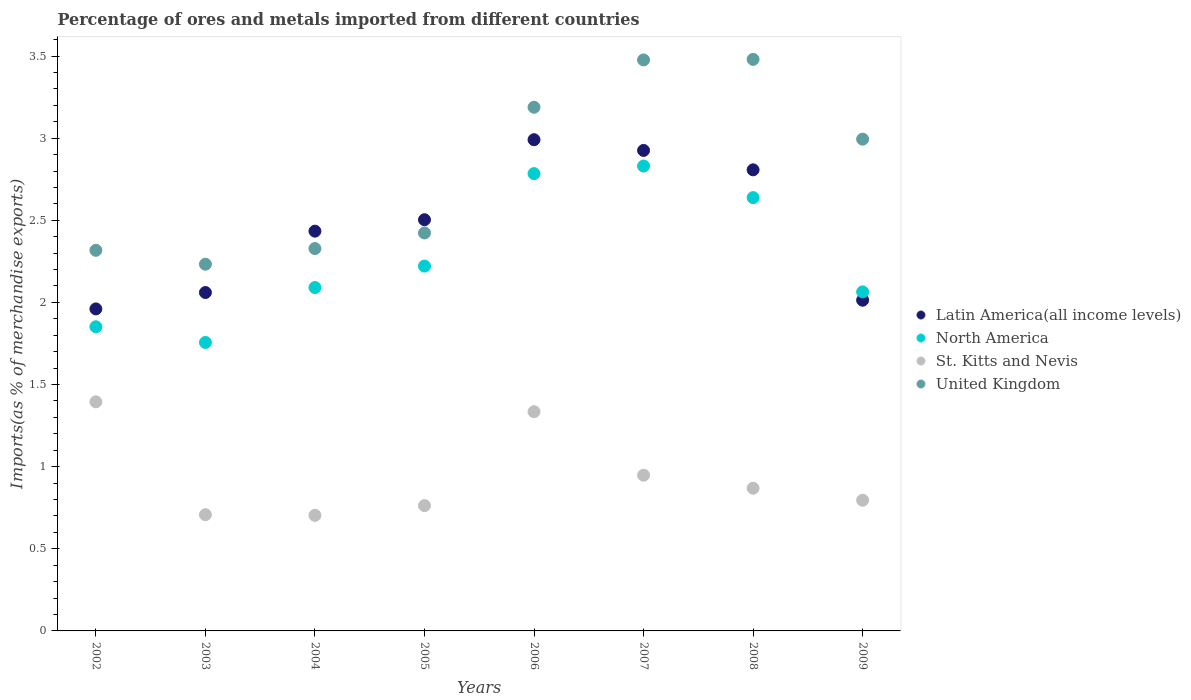How many different coloured dotlines are there?
Your answer should be compact. 4. Is the number of dotlines equal to the number of legend labels?
Keep it short and to the point. Yes. What is the percentage of imports to different countries in Latin America(all income levels) in 2007?
Provide a succinct answer. 2.93. Across all years, what is the maximum percentage of imports to different countries in United Kingdom?
Give a very brief answer. 3.48. Across all years, what is the minimum percentage of imports to different countries in Latin America(all income levels)?
Keep it short and to the point. 1.96. In which year was the percentage of imports to different countries in Latin America(all income levels) maximum?
Offer a very short reply. 2006. In which year was the percentage of imports to different countries in St. Kitts and Nevis minimum?
Provide a short and direct response. 2004. What is the total percentage of imports to different countries in St. Kitts and Nevis in the graph?
Your response must be concise. 7.52. What is the difference between the percentage of imports to different countries in North America in 2002 and that in 2005?
Your answer should be very brief. -0.37. What is the difference between the percentage of imports to different countries in St. Kitts and Nevis in 2006 and the percentage of imports to different countries in North America in 2002?
Offer a terse response. -0.52. What is the average percentage of imports to different countries in Latin America(all income levels) per year?
Make the answer very short. 2.46. In the year 2006, what is the difference between the percentage of imports to different countries in St. Kitts and Nevis and percentage of imports to different countries in North America?
Provide a succinct answer. -1.45. In how many years, is the percentage of imports to different countries in Latin America(all income levels) greater than 1.5 %?
Give a very brief answer. 8. What is the ratio of the percentage of imports to different countries in United Kingdom in 2006 to that in 2007?
Provide a short and direct response. 0.92. What is the difference between the highest and the second highest percentage of imports to different countries in Latin America(all income levels)?
Offer a terse response. 0.07. What is the difference between the highest and the lowest percentage of imports to different countries in Latin America(all income levels)?
Ensure brevity in your answer.  1.03. Is the sum of the percentage of imports to different countries in North America in 2005 and 2008 greater than the maximum percentage of imports to different countries in United Kingdom across all years?
Provide a short and direct response. Yes. Is it the case that in every year, the sum of the percentage of imports to different countries in North America and percentage of imports to different countries in United Kingdom  is greater than the sum of percentage of imports to different countries in St. Kitts and Nevis and percentage of imports to different countries in Latin America(all income levels)?
Provide a succinct answer. No. Is it the case that in every year, the sum of the percentage of imports to different countries in United Kingdom and percentage of imports to different countries in St. Kitts and Nevis  is greater than the percentage of imports to different countries in North America?
Keep it short and to the point. Yes. What is the difference between two consecutive major ticks on the Y-axis?
Your answer should be compact. 0.5. Where does the legend appear in the graph?
Ensure brevity in your answer.  Center right. How are the legend labels stacked?
Keep it short and to the point. Vertical. What is the title of the graph?
Give a very brief answer. Percentage of ores and metals imported from different countries. What is the label or title of the X-axis?
Make the answer very short. Years. What is the label or title of the Y-axis?
Keep it short and to the point. Imports(as % of merchandise exports). What is the Imports(as % of merchandise exports) of Latin America(all income levels) in 2002?
Provide a succinct answer. 1.96. What is the Imports(as % of merchandise exports) in North America in 2002?
Give a very brief answer. 1.85. What is the Imports(as % of merchandise exports) of St. Kitts and Nevis in 2002?
Provide a short and direct response. 1.39. What is the Imports(as % of merchandise exports) of United Kingdom in 2002?
Give a very brief answer. 2.32. What is the Imports(as % of merchandise exports) in Latin America(all income levels) in 2003?
Provide a short and direct response. 2.06. What is the Imports(as % of merchandise exports) of North America in 2003?
Your answer should be compact. 1.76. What is the Imports(as % of merchandise exports) in St. Kitts and Nevis in 2003?
Offer a terse response. 0.71. What is the Imports(as % of merchandise exports) of United Kingdom in 2003?
Provide a short and direct response. 2.23. What is the Imports(as % of merchandise exports) of Latin America(all income levels) in 2004?
Make the answer very short. 2.43. What is the Imports(as % of merchandise exports) in North America in 2004?
Provide a succinct answer. 2.09. What is the Imports(as % of merchandise exports) in St. Kitts and Nevis in 2004?
Your answer should be compact. 0.7. What is the Imports(as % of merchandise exports) in United Kingdom in 2004?
Your answer should be very brief. 2.33. What is the Imports(as % of merchandise exports) in Latin America(all income levels) in 2005?
Your answer should be very brief. 2.5. What is the Imports(as % of merchandise exports) of North America in 2005?
Provide a short and direct response. 2.22. What is the Imports(as % of merchandise exports) in St. Kitts and Nevis in 2005?
Ensure brevity in your answer.  0.76. What is the Imports(as % of merchandise exports) of United Kingdom in 2005?
Provide a short and direct response. 2.42. What is the Imports(as % of merchandise exports) of Latin America(all income levels) in 2006?
Provide a succinct answer. 2.99. What is the Imports(as % of merchandise exports) of North America in 2006?
Ensure brevity in your answer.  2.78. What is the Imports(as % of merchandise exports) of St. Kitts and Nevis in 2006?
Provide a succinct answer. 1.33. What is the Imports(as % of merchandise exports) of United Kingdom in 2006?
Your answer should be very brief. 3.19. What is the Imports(as % of merchandise exports) in Latin America(all income levels) in 2007?
Keep it short and to the point. 2.93. What is the Imports(as % of merchandise exports) of North America in 2007?
Offer a very short reply. 2.83. What is the Imports(as % of merchandise exports) of St. Kitts and Nevis in 2007?
Your answer should be very brief. 0.95. What is the Imports(as % of merchandise exports) of United Kingdom in 2007?
Your answer should be very brief. 3.48. What is the Imports(as % of merchandise exports) in Latin America(all income levels) in 2008?
Offer a terse response. 2.81. What is the Imports(as % of merchandise exports) in North America in 2008?
Give a very brief answer. 2.64. What is the Imports(as % of merchandise exports) of St. Kitts and Nevis in 2008?
Provide a short and direct response. 0.87. What is the Imports(as % of merchandise exports) in United Kingdom in 2008?
Provide a succinct answer. 3.48. What is the Imports(as % of merchandise exports) in Latin America(all income levels) in 2009?
Provide a succinct answer. 2.01. What is the Imports(as % of merchandise exports) of North America in 2009?
Offer a very short reply. 2.06. What is the Imports(as % of merchandise exports) in St. Kitts and Nevis in 2009?
Your answer should be very brief. 0.8. What is the Imports(as % of merchandise exports) in United Kingdom in 2009?
Offer a very short reply. 2.99. Across all years, what is the maximum Imports(as % of merchandise exports) in Latin America(all income levels)?
Your answer should be compact. 2.99. Across all years, what is the maximum Imports(as % of merchandise exports) in North America?
Provide a short and direct response. 2.83. Across all years, what is the maximum Imports(as % of merchandise exports) in St. Kitts and Nevis?
Give a very brief answer. 1.39. Across all years, what is the maximum Imports(as % of merchandise exports) in United Kingdom?
Give a very brief answer. 3.48. Across all years, what is the minimum Imports(as % of merchandise exports) in Latin America(all income levels)?
Your answer should be compact. 1.96. Across all years, what is the minimum Imports(as % of merchandise exports) of North America?
Ensure brevity in your answer.  1.76. Across all years, what is the minimum Imports(as % of merchandise exports) in St. Kitts and Nevis?
Offer a terse response. 0.7. Across all years, what is the minimum Imports(as % of merchandise exports) in United Kingdom?
Provide a succinct answer. 2.23. What is the total Imports(as % of merchandise exports) in Latin America(all income levels) in the graph?
Keep it short and to the point. 19.69. What is the total Imports(as % of merchandise exports) of North America in the graph?
Your answer should be very brief. 18.24. What is the total Imports(as % of merchandise exports) of St. Kitts and Nevis in the graph?
Provide a succinct answer. 7.52. What is the total Imports(as % of merchandise exports) of United Kingdom in the graph?
Keep it short and to the point. 22.44. What is the difference between the Imports(as % of merchandise exports) of Latin America(all income levels) in 2002 and that in 2003?
Ensure brevity in your answer.  -0.1. What is the difference between the Imports(as % of merchandise exports) of North America in 2002 and that in 2003?
Your response must be concise. 0.1. What is the difference between the Imports(as % of merchandise exports) in St. Kitts and Nevis in 2002 and that in 2003?
Keep it short and to the point. 0.69. What is the difference between the Imports(as % of merchandise exports) in United Kingdom in 2002 and that in 2003?
Offer a terse response. 0.08. What is the difference between the Imports(as % of merchandise exports) in Latin America(all income levels) in 2002 and that in 2004?
Make the answer very short. -0.47. What is the difference between the Imports(as % of merchandise exports) of North America in 2002 and that in 2004?
Your answer should be compact. -0.24. What is the difference between the Imports(as % of merchandise exports) of St. Kitts and Nevis in 2002 and that in 2004?
Give a very brief answer. 0.69. What is the difference between the Imports(as % of merchandise exports) of United Kingdom in 2002 and that in 2004?
Offer a terse response. -0.01. What is the difference between the Imports(as % of merchandise exports) of Latin America(all income levels) in 2002 and that in 2005?
Give a very brief answer. -0.54. What is the difference between the Imports(as % of merchandise exports) in North America in 2002 and that in 2005?
Offer a terse response. -0.37. What is the difference between the Imports(as % of merchandise exports) of St. Kitts and Nevis in 2002 and that in 2005?
Provide a succinct answer. 0.63. What is the difference between the Imports(as % of merchandise exports) in United Kingdom in 2002 and that in 2005?
Your answer should be very brief. -0.11. What is the difference between the Imports(as % of merchandise exports) of Latin America(all income levels) in 2002 and that in 2006?
Provide a short and direct response. -1.03. What is the difference between the Imports(as % of merchandise exports) of North America in 2002 and that in 2006?
Your response must be concise. -0.93. What is the difference between the Imports(as % of merchandise exports) in St. Kitts and Nevis in 2002 and that in 2006?
Your answer should be compact. 0.06. What is the difference between the Imports(as % of merchandise exports) of United Kingdom in 2002 and that in 2006?
Offer a terse response. -0.87. What is the difference between the Imports(as % of merchandise exports) in Latin America(all income levels) in 2002 and that in 2007?
Provide a short and direct response. -0.96. What is the difference between the Imports(as % of merchandise exports) of North America in 2002 and that in 2007?
Your answer should be compact. -0.98. What is the difference between the Imports(as % of merchandise exports) in St. Kitts and Nevis in 2002 and that in 2007?
Offer a very short reply. 0.45. What is the difference between the Imports(as % of merchandise exports) of United Kingdom in 2002 and that in 2007?
Give a very brief answer. -1.16. What is the difference between the Imports(as % of merchandise exports) of Latin America(all income levels) in 2002 and that in 2008?
Make the answer very short. -0.85. What is the difference between the Imports(as % of merchandise exports) of North America in 2002 and that in 2008?
Keep it short and to the point. -0.79. What is the difference between the Imports(as % of merchandise exports) in St. Kitts and Nevis in 2002 and that in 2008?
Offer a terse response. 0.53. What is the difference between the Imports(as % of merchandise exports) of United Kingdom in 2002 and that in 2008?
Give a very brief answer. -1.16. What is the difference between the Imports(as % of merchandise exports) of Latin America(all income levels) in 2002 and that in 2009?
Provide a short and direct response. -0.05. What is the difference between the Imports(as % of merchandise exports) in North America in 2002 and that in 2009?
Give a very brief answer. -0.21. What is the difference between the Imports(as % of merchandise exports) of St. Kitts and Nevis in 2002 and that in 2009?
Ensure brevity in your answer.  0.6. What is the difference between the Imports(as % of merchandise exports) of United Kingdom in 2002 and that in 2009?
Keep it short and to the point. -0.68. What is the difference between the Imports(as % of merchandise exports) in Latin America(all income levels) in 2003 and that in 2004?
Your response must be concise. -0.37. What is the difference between the Imports(as % of merchandise exports) of North America in 2003 and that in 2004?
Provide a succinct answer. -0.33. What is the difference between the Imports(as % of merchandise exports) in St. Kitts and Nevis in 2003 and that in 2004?
Give a very brief answer. 0. What is the difference between the Imports(as % of merchandise exports) in United Kingdom in 2003 and that in 2004?
Provide a short and direct response. -0.1. What is the difference between the Imports(as % of merchandise exports) in Latin America(all income levels) in 2003 and that in 2005?
Offer a very short reply. -0.44. What is the difference between the Imports(as % of merchandise exports) of North America in 2003 and that in 2005?
Ensure brevity in your answer.  -0.47. What is the difference between the Imports(as % of merchandise exports) in St. Kitts and Nevis in 2003 and that in 2005?
Your answer should be compact. -0.06. What is the difference between the Imports(as % of merchandise exports) in United Kingdom in 2003 and that in 2005?
Offer a terse response. -0.19. What is the difference between the Imports(as % of merchandise exports) of Latin America(all income levels) in 2003 and that in 2006?
Make the answer very short. -0.93. What is the difference between the Imports(as % of merchandise exports) in North America in 2003 and that in 2006?
Your response must be concise. -1.03. What is the difference between the Imports(as % of merchandise exports) of St. Kitts and Nevis in 2003 and that in 2006?
Make the answer very short. -0.63. What is the difference between the Imports(as % of merchandise exports) in United Kingdom in 2003 and that in 2006?
Provide a short and direct response. -0.96. What is the difference between the Imports(as % of merchandise exports) of Latin America(all income levels) in 2003 and that in 2007?
Ensure brevity in your answer.  -0.87. What is the difference between the Imports(as % of merchandise exports) in North America in 2003 and that in 2007?
Keep it short and to the point. -1.07. What is the difference between the Imports(as % of merchandise exports) of St. Kitts and Nevis in 2003 and that in 2007?
Provide a short and direct response. -0.24. What is the difference between the Imports(as % of merchandise exports) of United Kingdom in 2003 and that in 2007?
Your response must be concise. -1.24. What is the difference between the Imports(as % of merchandise exports) of Latin America(all income levels) in 2003 and that in 2008?
Give a very brief answer. -0.75. What is the difference between the Imports(as % of merchandise exports) in North America in 2003 and that in 2008?
Offer a very short reply. -0.88. What is the difference between the Imports(as % of merchandise exports) in St. Kitts and Nevis in 2003 and that in 2008?
Your answer should be compact. -0.16. What is the difference between the Imports(as % of merchandise exports) in United Kingdom in 2003 and that in 2008?
Your answer should be compact. -1.25. What is the difference between the Imports(as % of merchandise exports) of Latin America(all income levels) in 2003 and that in 2009?
Make the answer very short. 0.05. What is the difference between the Imports(as % of merchandise exports) of North America in 2003 and that in 2009?
Ensure brevity in your answer.  -0.31. What is the difference between the Imports(as % of merchandise exports) of St. Kitts and Nevis in 2003 and that in 2009?
Your answer should be very brief. -0.09. What is the difference between the Imports(as % of merchandise exports) in United Kingdom in 2003 and that in 2009?
Your answer should be very brief. -0.76. What is the difference between the Imports(as % of merchandise exports) of Latin America(all income levels) in 2004 and that in 2005?
Your answer should be very brief. -0.07. What is the difference between the Imports(as % of merchandise exports) in North America in 2004 and that in 2005?
Your answer should be compact. -0.13. What is the difference between the Imports(as % of merchandise exports) of St. Kitts and Nevis in 2004 and that in 2005?
Provide a succinct answer. -0.06. What is the difference between the Imports(as % of merchandise exports) of United Kingdom in 2004 and that in 2005?
Provide a short and direct response. -0.1. What is the difference between the Imports(as % of merchandise exports) of Latin America(all income levels) in 2004 and that in 2006?
Your answer should be compact. -0.56. What is the difference between the Imports(as % of merchandise exports) in North America in 2004 and that in 2006?
Your response must be concise. -0.69. What is the difference between the Imports(as % of merchandise exports) in St. Kitts and Nevis in 2004 and that in 2006?
Provide a short and direct response. -0.63. What is the difference between the Imports(as % of merchandise exports) in United Kingdom in 2004 and that in 2006?
Your answer should be very brief. -0.86. What is the difference between the Imports(as % of merchandise exports) in Latin America(all income levels) in 2004 and that in 2007?
Keep it short and to the point. -0.49. What is the difference between the Imports(as % of merchandise exports) in North America in 2004 and that in 2007?
Provide a short and direct response. -0.74. What is the difference between the Imports(as % of merchandise exports) of St. Kitts and Nevis in 2004 and that in 2007?
Keep it short and to the point. -0.24. What is the difference between the Imports(as % of merchandise exports) of United Kingdom in 2004 and that in 2007?
Provide a short and direct response. -1.15. What is the difference between the Imports(as % of merchandise exports) of Latin America(all income levels) in 2004 and that in 2008?
Offer a terse response. -0.37. What is the difference between the Imports(as % of merchandise exports) of North America in 2004 and that in 2008?
Offer a terse response. -0.55. What is the difference between the Imports(as % of merchandise exports) in St. Kitts and Nevis in 2004 and that in 2008?
Give a very brief answer. -0.17. What is the difference between the Imports(as % of merchandise exports) of United Kingdom in 2004 and that in 2008?
Provide a short and direct response. -1.15. What is the difference between the Imports(as % of merchandise exports) in Latin America(all income levels) in 2004 and that in 2009?
Make the answer very short. 0.42. What is the difference between the Imports(as % of merchandise exports) of North America in 2004 and that in 2009?
Provide a succinct answer. 0.03. What is the difference between the Imports(as % of merchandise exports) of St. Kitts and Nevis in 2004 and that in 2009?
Provide a succinct answer. -0.09. What is the difference between the Imports(as % of merchandise exports) in United Kingdom in 2004 and that in 2009?
Keep it short and to the point. -0.67. What is the difference between the Imports(as % of merchandise exports) in Latin America(all income levels) in 2005 and that in 2006?
Your answer should be compact. -0.49. What is the difference between the Imports(as % of merchandise exports) in North America in 2005 and that in 2006?
Give a very brief answer. -0.56. What is the difference between the Imports(as % of merchandise exports) in St. Kitts and Nevis in 2005 and that in 2006?
Ensure brevity in your answer.  -0.57. What is the difference between the Imports(as % of merchandise exports) of United Kingdom in 2005 and that in 2006?
Provide a succinct answer. -0.77. What is the difference between the Imports(as % of merchandise exports) of Latin America(all income levels) in 2005 and that in 2007?
Your answer should be very brief. -0.42. What is the difference between the Imports(as % of merchandise exports) of North America in 2005 and that in 2007?
Keep it short and to the point. -0.61. What is the difference between the Imports(as % of merchandise exports) in St. Kitts and Nevis in 2005 and that in 2007?
Offer a terse response. -0.19. What is the difference between the Imports(as % of merchandise exports) of United Kingdom in 2005 and that in 2007?
Offer a terse response. -1.05. What is the difference between the Imports(as % of merchandise exports) in Latin America(all income levels) in 2005 and that in 2008?
Keep it short and to the point. -0.3. What is the difference between the Imports(as % of merchandise exports) of North America in 2005 and that in 2008?
Your answer should be very brief. -0.42. What is the difference between the Imports(as % of merchandise exports) in St. Kitts and Nevis in 2005 and that in 2008?
Provide a short and direct response. -0.11. What is the difference between the Imports(as % of merchandise exports) in United Kingdom in 2005 and that in 2008?
Offer a very short reply. -1.06. What is the difference between the Imports(as % of merchandise exports) in Latin America(all income levels) in 2005 and that in 2009?
Your answer should be very brief. 0.49. What is the difference between the Imports(as % of merchandise exports) of North America in 2005 and that in 2009?
Your answer should be very brief. 0.16. What is the difference between the Imports(as % of merchandise exports) in St. Kitts and Nevis in 2005 and that in 2009?
Your response must be concise. -0.03. What is the difference between the Imports(as % of merchandise exports) in United Kingdom in 2005 and that in 2009?
Give a very brief answer. -0.57. What is the difference between the Imports(as % of merchandise exports) of Latin America(all income levels) in 2006 and that in 2007?
Keep it short and to the point. 0.07. What is the difference between the Imports(as % of merchandise exports) in North America in 2006 and that in 2007?
Ensure brevity in your answer.  -0.05. What is the difference between the Imports(as % of merchandise exports) of St. Kitts and Nevis in 2006 and that in 2007?
Your answer should be compact. 0.39. What is the difference between the Imports(as % of merchandise exports) of United Kingdom in 2006 and that in 2007?
Your response must be concise. -0.29. What is the difference between the Imports(as % of merchandise exports) in Latin America(all income levels) in 2006 and that in 2008?
Your answer should be very brief. 0.18. What is the difference between the Imports(as % of merchandise exports) in North America in 2006 and that in 2008?
Make the answer very short. 0.15. What is the difference between the Imports(as % of merchandise exports) of St. Kitts and Nevis in 2006 and that in 2008?
Your answer should be very brief. 0.47. What is the difference between the Imports(as % of merchandise exports) in United Kingdom in 2006 and that in 2008?
Make the answer very short. -0.29. What is the difference between the Imports(as % of merchandise exports) of Latin America(all income levels) in 2006 and that in 2009?
Provide a short and direct response. 0.98. What is the difference between the Imports(as % of merchandise exports) in North America in 2006 and that in 2009?
Your response must be concise. 0.72. What is the difference between the Imports(as % of merchandise exports) of St. Kitts and Nevis in 2006 and that in 2009?
Ensure brevity in your answer.  0.54. What is the difference between the Imports(as % of merchandise exports) of United Kingdom in 2006 and that in 2009?
Your answer should be very brief. 0.19. What is the difference between the Imports(as % of merchandise exports) of Latin America(all income levels) in 2007 and that in 2008?
Your answer should be very brief. 0.12. What is the difference between the Imports(as % of merchandise exports) of North America in 2007 and that in 2008?
Make the answer very short. 0.19. What is the difference between the Imports(as % of merchandise exports) in St. Kitts and Nevis in 2007 and that in 2008?
Provide a short and direct response. 0.08. What is the difference between the Imports(as % of merchandise exports) of United Kingdom in 2007 and that in 2008?
Provide a short and direct response. -0. What is the difference between the Imports(as % of merchandise exports) of Latin America(all income levels) in 2007 and that in 2009?
Ensure brevity in your answer.  0.91. What is the difference between the Imports(as % of merchandise exports) of North America in 2007 and that in 2009?
Your answer should be very brief. 0.77. What is the difference between the Imports(as % of merchandise exports) in St. Kitts and Nevis in 2007 and that in 2009?
Give a very brief answer. 0.15. What is the difference between the Imports(as % of merchandise exports) of United Kingdom in 2007 and that in 2009?
Keep it short and to the point. 0.48. What is the difference between the Imports(as % of merchandise exports) in Latin America(all income levels) in 2008 and that in 2009?
Offer a very short reply. 0.79. What is the difference between the Imports(as % of merchandise exports) in North America in 2008 and that in 2009?
Offer a very short reply. 0.57. What is the difference between the Imports(as % of merchandise exports) of St. Kitts and Nevis in 2008 and that in 2009?
Your response must be concise. 0.07. What is the difference between the Imports(as % of merchandise exports) of United Kingdom in 2008 and that in 2009?
Offer a terse response. 0.49. What is the difference between the Imports(as % of merchandise exports) in Latin America(all income levels) in 2002 and the Imports(as % of merchandise exports) in North America in 2003?
Keep it short and to the point. 0.2. What is the difference between the Imports(as % of merchandise exports) of Latin America(all income levels) in 2002 and the Imports(as % of merchandise exports) of St. Kitts and Nevis in 2003?
Ensure brevity in your answer.  1.25. What is the difference between the Imports(as % of merchandise exports) in Latin America(all income levels) in 2002 and the Imports(as % of merchandise exports) in United Kingdom in 2003?
Your answer should be compact. -0.27. What is the difference between the Imports(as % of merchandise exports) in North America in 2002 and the Imports(as % of merchandise exports) in St. Kitts and Nevis in 2003?
Your response must be concise. 1.14. What is the difference between the Imports(as % of merchandise exports) of North America in 2002 and the Imports(as % of merchandise exports) of United Kingdom in 2003?
Ensure brevity in your answer.  -0.38. What is the difference between the Imports(as % of merchandise exports) in St. Kitts and Nevis in 2002 and the Imports(as % of merchandise exports) in United Kingdom in 2003?
Your answer should be compact. -0.84. What is the difference between the Imports(as % of merchandise exports) of Latin America(all income levels) in 2002 and the Imports(as % of merchandise exports) of North America in 2004?
Ensure brevity in your answer.  -0.13. What is the difference between the Imports(as % of merchandise exports) of Latin America(all income levels) in 2002 and the Imports(as % of merchandise exports) of St. Kitts and Nevis in 2004?
Your answer should be very brief. 1.26. What is the difference between the Imports(as % of merchandise exports) of Latin America(all income levels) in 2002 and the Imports(as % of merchandise exports) of United Kingdom in 2004?
Offer a terse response. -0.37. What is the difference between the Imports(as % of merchandise exports) in North America in 2002 and the Imports(as % of merchandise exports) in St. Kitts and Nevis in 2004?
Make the answer very short. 1.15. What is the difference between the Imports(as % of merchandise exports) in North America in 2002 and the Imports(as % of merchandise exports) in United Kingdom in 2004?
Provide a succinct answer. -0.48. What is the difference between the Imports(as % of merchandise exports) in St. Kitts and Nevis in 2002 and the Imports(as % of merchandise exports) in United Kingdom in 2004?
Keep it short and to the point. -0.93. What is the difference between the Imports(as % of merchandise exports) of Latin America(all income levels) in 2002 and the Imports(as % of merchandise exports) of North America in 2005?
Ensure brevity in your answer.  -0.26. What is the difference between the Imports(as % of merchandise exports) in Latin America(all income levels) in 2002 and the Imports(as % of merchandise exports) in St. Kitts and Nevis in 2005?
Offer a very short reply. 1.2. What is the difference between the Imports(as % of merchandise exports) in Latin America(all income levels) in 2002 and the Imports(as % of merchandise exports) in United Kingdom in 2005?
Provide a succinct answer. -0.46. What is the difference between the Imports(as % of merchandise exports) in North America in 2002 and the Imports(as % of merchandise exports) in St. Kitts and Nevis in 2005?
Provide a succinct answer. 1.09. What is the difference between the Imports(as % of merchandise exports) of North America in 2002 and the Imports(as % of merchandise exports) of United Kingdom in 2005?
Keep it short and to the point. -0.57. What is the difference between the Imports(as % of merchandise exports) in St. Kitts and Nevis in 2002 and the Imports(as % of merchandise exports) in United Kingdom in 2005?
Provide a succinct answer. -1.03. What is the difference between the Imports(as % of merchandise exports) of Latin America(all income levels) in 2002 and the Imports(as % of merchandise exports) of North America in 2006?
Offer a terse response. -0.82. What is the difference between the Imports(as % of merchandise exports) of Latin America(all income levels) in 2002 and the Imports(as % of merchandise exports) of St. Kitts and Nevis in 2006?
Make the answer very short. 0.63. What is the difference between the Imports(as % of merchandise exports) of Latin America(all income levels) in 2002 and the Imports(as % of merchandise exports) of United Kingdom in 2006?
Your answer should be compact. -1.23. What is the difference between the Imports(as % of merchandise exports) of North America in 2002 and the Imports(as % of merchandise exports) of St. Kitts and Nevis in 2006?
Provide a succinct answer. 0.52. What is the difference between the Imports(as % of merchandise exports) of North America in 2002 and the Imports(as % of merchandise exports) of United Kingdom in 2006?
Your answer should be very brief. -1.34. What is the difference between the Imports(as % of merchandise exports) in St. Kitts and Nevis in 2002 and the Imports(as % of merchandise exports) in United Kingdom in 2006?
Ensure brevity in your answer.  -1.79. What is the difference between the Imports(as % of merchandise exports) of Latin America(all income levels) in 2002 and the Imports(as % of merchandise exports) of North America in 2007?
Ensure brevity in your answer.  -0.87. What is the difference between the Imports(as % of merchandise exports) in Latin America(all income levels) in 2002 and the Imports(as % of merchandise exports) in St. Kitts and Nevis in 2007?
Provide a succinct answer. 1.01. What is the difference between the Imports(as % of merchandise exports) in Latin America(all income levels) in 2002 and the Imports(as % of merchandise exports) in United Kingdom in 2007?
Keep it short and to the point. -1.52. What is the difference between the Imports(as % of merchandise exports) of North America in 2002 and the Imports(as % of merchandise exports) of St. Kitts and Nevis in 2007?
Offer a terse response. 0.9. What is the difference between the Imports(as % of merchandise exports) of North America in 2002 and the Imports(as % of merchandise exports) of United Kingdom in 2007?
Make the answer very short. -1.62. What is the difference between the Imports(as % of merchandise exports) in St. Kitts and Nevis in 2002 and the Imports(as % of merchandise exports) in United Kingdom in 2007?
Keep it short and to the point. -2.08. What is the difference between the Imports(as % of merchandise exports) in Latin America(all income levels) in 2002 and the Imports(as % of merchandise exports) in North America in 2008?
Your response must be concise. -0.68. What is the difference between the Imports(as % of merchandise exports) of Latin America(all income levels) in 2002 and the Imports(as % of merchandise exports) of St. Kitts and Nevis in 2008?
Your response must be concise. 1.09. What is the difference between the Imports(as % of merchandise exports) in Latin America(all income levels) in 2002 and the Imports(as % of merchandise exports) in United Kingdom in 2008?
Provide a succinct answer. -1.52. What is the difference between the Imports(as % of merchandise exports) of North America in 2002 and the Imports(as % of merchandise exports) of St. Kitts and Nevis in 2008?
Make the answer very short. 0.98. What is the difference between the Imports(as % of merchandise exports) in North America in 2002 and the Imports(as % of merchandise exports) in United Kingdom in 2008?
Your response must be concise. -1.63. What is the difference between the Imports(as % of merchandise exports) of St. Kitts and Nevis in 2002 and the Imports(as % of merchandise exports) of United Kingdom in 2008?
Provide a succinct answer. -2.08. What is the difference between the Imports(as % of merchandise exports) of Latin America(all income levels) in 2002 and the Imports(as % of merchandise exports) of North America in 2009?
Your answer should be compact. -0.1. What is the difference between the Imports(as % of merchandise exports) of Latin America(all income levels) in 2002 and the Imports(as % of merchandise exports) of St. Kitts and Nevis in 2009?
Your response must be concise. 1.16. What is the difference between the Imports(as % of merchandise exports) in Latin America(all income levels) in 2002 and the Imports(as % of merchandise exports) in United Kingdom in 2009?
Offer a very short reply. -1.03. What is the difference between the Imports(as % of merchandise exports) in North America in 2002 and the Imports(as % of merchandise exports) in St. Kitts and Nevis in 2009?
Offer a terse response. 1.06. What is the difference between the Imports(as % of merchandise exports) of North America in 2002 and the Imports(as % of merchandise exports) of United Kingdom in 2009?
Make the answer very short. -1.14. What is the difference between the Imports(as % of merchandise exports) in St. Kitts and Nevis in 2002 and the Imports(as % of merchandise exports) in United Kingdom in 2009?
Your answer should be very brief. -1.6. What is the difference between the Imports(as % of merchandise exports) of Latin America(all income levels) in 2003 and the Imports(as % of merchandise exports) of North America in 2004?
Provide a short and direct response. -0.03. What is the difference between the Imports(as % of merchandise exports) in Latin America(all income levels) in 2003 and the Imports(as % of merchandise exports) in St. Kitts and Nevis in 2004?
Make the answer very short. 1.36. What is the difference between the Imports(as % of merchandise exports) in Latin America(all income levels) in 2003 and the Imports(as % of merchandise exports) in United Kingdom in 2004?
Provide a short and direct response. -0.27. What is the difference between the Imports(as % of merchandise exports) in North America in 2003 and the Imports(as % of merchandise exports) in St. Kitts and Nevis in 2004?
Keep it short and to the point. 1.05. What is the difference between the Imports(as % of merchandise exports) of North America in 2003 and the Imports(as % of merchandise exports) of United Kingdom in 2004?
Offer a very short reply. -0.57. What is the difference between the Imports(as % of merchandise exports) in St. Kitts and Nevis in 2003 and the Imports(as % of merchandise exports) in United Kingdom in 2004?
Offer a terse response. -1.62. What is the difference between the Imports(as % of merchandise exports) in Latin America(all income levels) in 2003 and the Imports(as % of merchandise exports) in North America in 2005?
Provide a short and direct response. -0.16. What is the difference between the Imports(as % of merchandise exports) in Latin America(all income levels) in 2003 and the Imports(as % of merchandise exports) in St. Kitts and Nevis in 2005?
Offer a very short reply. 1.3. What is the difference between the Imports(as % of merchandise exports) of Latin America(all income levels) in 2003 and the Imports(as % of merchandise exports) of United Kingdom in 2005?
Ensure brevity in your answer.  -0.36. What is the difference between the Imports(as % of merchandise exports) of North America in 2003 and the Imports(as % of merchandise exports) of United Kingdom in 2005?
Offer a very short reply. -0.67. What is the difference between the Imports(as % of merchandise exports) in St. Kitts and Nevis in 2003 and the Imports(as % of merchandise exports) in United Kingdom in 2005?
Offer a terse response. -1.72. What is the difference between the Imports(as % of merchandise exports) in Latin America(all income levels) in 2003 and the Imports(as % of merchandise exports) in North America in 2006?
Make the answer very short. -0.72. What is the difference between the Imports(as % of merchandise exports) in Latin America(all income levels) in 2003 and the Imports(as % of merchandise exports) in St. Kitts and Nevis in 2006?
Your answer should be very brief. 0.73. What is the difference between the Imports(as % of merchandise exports) in Latin America(all income levels) in 2003 and the Imports(as % of merchandise exports) in United Kingdom in 2006?
Provide a short and direct response. -1.13. What is the difference between the Imports(as % of merchandise exports) of North America in 2003 and the Imports(as % of merchandise exports) of St. Kitts and Nevis in 2006?
Keep it short and to the point. 0.42. What is the difference between the Imports(as % of merchandise exports) of North America in 2003 and the Imports(as % of merchandise exports) of United Kingdom in 2006?
Keep it short and to the point. -1.43. What is the difference between the Imports(as % of merchandise exports) of St. Kitts and Nevis in 2003 and the Imports(as % of merchandise exports) of United Kingdom in 2006?
Give a very brief answer. -2.48. What is the difference between the Imports(as % of merchandise exports) of Latin America(all income levels) in 2003 and the Imports(as % of merchandise exports) of North America in 2007?
Provide a succinct answer. -0.77. What is the difference between the Imports(as % of merchandise exports) of Latin America(all income levels) in 2003 and the Imports(as % of merchandise exports) of St. Kitts and Nevis in 2007?
Make the answer very short. 1.11. What is the difference between the Imports(as % of merchandise exports) in Latin America(all income levels) in 2003 and the Imports(as % of merchandise exports) in United Kingdom in 2007?
Make the answer very short. -1.42. What is the difference between the Imports(as % of merchandise exports) of North America in 2003 and the Imports(as % of merchandise exports) of St. Kitts and Nevis in 2007?
Your answer should be compact. 0.81. What is the difference between the Imports(as % of merchandise exports) of North America in 2003 and the Imports(as % of merchandise exports) of United Kingdom in 2007?
Your response must be concise. -1.72. What is the difference between the Imports(as % of merchandise exports) in St. Kitts and Nevis in 2003 and the Imports(as % of merchandise exports) in United Kingdom in 2007?
Your response must be concise. -2.77. What is the difference between the Imports(as % of merchandise exports) in Latin America(all income levels) in 2003 and the Imports(as % of merchandise exports) in North America in 2008?
Keep it short and to the point. -0.58. What is the difference between the Imports(as % of merchandise exports) in Latin America(all income levels) in 2003 and the Imports(as % of merchandise exports) in St. Kitts and Nevis in 2008?
Offer a terse response. 1.19. What is the difference between the Imports(as % of merchandise exports) in Latin America(all income levels) in 2003 and the Imports(as % of merchandise exports) in United Kingdom in 2008?
Make the answer very short. -1.42. What is the difference between the Imports(as % of merchandise exports) of North America in 2003 and the Imports(as % of merchandise exports) of St. Kitts and Nevis in 2008?
Provide a short and direct response. 0.89. What is the difference between the Imports(as % of merchandise exports) in North America in 2003 and the Imports(as % of merchandise exports) in United Kingdom in 2008?
Give a very brief answer. -1.72. What is the difference between the Imports(as % of merchandise exports) of St. Kitts and Nevis in 2003 and the Imports(as % of merchandise exports) of United Kingdom in 2008?
Offer a terse response. -2.77. What is the difference between the Imports(as % of merchandise exports) of Latin America(all income levels) in 2003 and the Imports(as % of merchandise exports) of North America in 2009?
Provide a short and direct response. -0. What is the difference between the Imports(as % of merchandise exports) of Latin America(all income levels) in 2003 and the Imports(as % of merchandise exports) of St. Kitts and Nevis in 2009?
Give a very brief answer. 1.26. What is the difference between the Imports(as % of merchandise exports) in Latin America(all income levels) in 2003 and the Imports(as % of merchandise exports) in United Kingdom in 2009?
Offer a very short reply. -0.93. What is the difference between the Imports(as % of merchandise exports) of North America in 2003 and the Imports(as % of merchandise exports) of St. Kitts and Nevis in 2009?
Ensure brevity in your answer.  0.96. What is the difference between the Imports(as % of merchandise exports) in North America in 2003 and the Imports(as % of merchandise exports) in United Kingdom in 2009?
Provide a short and direct response. -1.24. What is the difference between the Imports(as % of merchandise exports) in St. Kitts and Nevis in 2003 and the Imports(as % of merchandise exports) in United Kingdom in 2009?
Your answer should be very brief. -2.29. What is the difference between the Imports(as % of merchandise exports) in Latin America(all income levels) in 2004 and the Imports(as % of merchandise exports) in North America in 2005?
Ensure brevity in your answer.  0.21. What is the difference between the Imports(as % of merchandise exports) in Latin America(all income levels) in 2004 and the Imports(as % of merchandise exports) in St. Kitts and Nevis in 2005?
Make the answer very short. 1.67. What is the difference between the Imports(as % of merchandise exports) in Latin America(all income levels) in 2004 and the Imports(as % of merchandise exports) in United Kingdom in 2005?
Make the answer very short. 0.01. What is the difference between the Imports(as % of merchandise exports) in North America in 2004 and the Imports(as % of merchandise exports) in St. Kitts and Nevis in 2005?
Your answer should be compact. 1.33. What is the difference between the Imports(as % of merchandise exports) in North America in 2004 and the Imports(as % of merchandise exports) in United Kingdom in 2005?
Keep it short and to the point. -0.33. What is the difference between the Imports(as % of merchandise exports) in St. Kitts and Nevis in 2004 and the Imports(as % of merchandise exports) in United Kingdom in 2005?
Provide a succinct answer. -1.72. What is the difference between the Imports(as % of merchandise exports) of Latin America(all income levels) in 2004 and the Imports(as % of merchandise exports) of North America in 2006?
Ensure brevity in your answer.  -0.35. What is the difference between the Imports(as % of merchandise exports) in Latin America(all income levels) in 2004 and the Imports(as % of merchandise exports) in St. Kitts and Nevis in 2006?
Make the answer very short. 1.1. What is the difference between the Imports(as % of merchandise exports) of Latin America(all income levels) in 2004 and the Imports(as % of merchandise exports) of United Kingdom in 2006?
Make the answer very short. -0.75. What is the difference between the Imports(as % of merchandise exports) in North America in 2004 and the Imports(as % of merchandise exports) in St. Kitts and Nevis in 2006?
Your answer should be compact. 0.76. What is the difference between the Imports(as % of merchandise exports) in North America in 2004 and the Imports(as % of merchandise exports) in United Kingdom in 2006?
Your answer should be compact. -1.1. What is the difference between the Imports(as % of merchandise exports) in St. Kitts and Nevis in 2004 and the Imports(as % of merchandise exports) in United Kingdom in 2006?
Your response must be concise. -2.48. What is the difference between the Imports(as % of merchandise exports) in Latin America(all income levels) in 2004 and the Imports(as % of merchandise exports) in North America in 2007?
Your answer should be compact. -0.4. What is the difference between the Imports(as % of merchandise exports) in Latin America(all income levels) in 2004 and the Imports(as % of merchandise exports) in St. Kitts and Nevis in 2007?
Ensure brevity in your answer.  1.49. What is the difference between the Imports(as % of merchandise exports) in Latin America(all income levels) in 2004 and the Imports(as % of merchandise exports) in United Kingdom in 2007?
Provide a short and direct response. -1.04. What is the difference between the Imports(as % of merchandise exports) of North America in 2004 and the Imports(as % of merchandise exports) of St. Kitts and Nevis in 2007?
Your answer should be very brief. 1.14. What is the difference between the Imports(as % of merchandise exports) of North America in 2004 and the Imports(as % of merchandise exports) of United Kingdom in 2007?
Your answer should be compact. -1.39. What is the difference between the Imports(as % of merchandise exports) in St. Kitts and Nevis in 2004 and the Imports(as % of merchandise exports) in United Kingdom in 2007?
Your answer should be compact. -2.77. What is the difference between the Imports(as % of merchandise exports) in Latin America(all income levels) in 2004 and the Imports(as % of merchandise exports) in North America in 2008?
Ensure brevity in your answer.  -0.2. What is the difference between the Imports(as % of merchandise exports) of Latin America(all income levels) in 2004 and the Imports(as % of merchandise exports) of St. Kitts and Nevis in 2008?
Your response must be concise. 1.56. What is the difference between the Imports(as % of merchandise exports) of Latin America(all income levels) in 2004 and the Imports(as % of merchandise exports) of United Kingdom in 2008?
Offer a very short reply. -1.05. What is the difference between the Imports(as % of merchandise exports) in North America in 2004 and the Imports(as % of merchandise exports) in St. Kitts and Nevis in 2008?
Provide a short and direct response. 1.22. What is the difference between the Imports(as % of merchandise exports) in North America in 2004 and the Imports(as % of merchandise exports) in United Kingdom in 2008?
Your response must be concise. -1.39. What is the difference between the Imports(as % of merchandise exports) of St. Kitts and Nevis in 2004 and the Imports(as % of merchandise exports) of United Kingdom in 2008?
Ensure brevity in your answer.  -2.78. What is the difference between the Imports(as % of merchandise exports) in Latin America(all income levels) in 2004 and the Imports(as % of merchandise exports) in North America in 2009?
Offer a very short reply. 0.37. What is the difference between the Imports(as % of merchandise exports) of Latin America(all income levels) in 2004 and the Imports(as % of merchandise exports) of St. Kitts and Nevis in 2009?
Give a very brief answer. 1.64. What is the difference between the Imports(as % of merchandise exports) in Latin America(all income levels) in 2004 and the Imports(as % of merchandise exports) in United Kingdom in 2009?
Offer a very short reply. -0.56. What is the difference between the Imports(as % of merchandise exports) in North America in 2004 and the Imports(as % of merchandise exports) in St. Kitts and Nevis in 2009?
Offer a terse response. 1.29. What is the difference between the Imports(as % of merchandise exports) of North America in 2004 and the Imports(as % of merchandise exports) of United Kingdom in 2009?
Give a very brief answer. -0.9. What is the difference between the Imports(as % of merchandise exports) of St. Kitts and Nevis in 2004 and the Imports(as % of merchandise exports) of United Kingdom in 2009?
Your answer should be very brief. -2.29. What is the difference between the Imports(as % of merchandise exports) in Latin America(all income levels) in 2005 and the Imports(as % of merchandise exports) in North America in 2006?
Your answer should be compact. -0.28. What is the difference between the Imports(as % of merchandise exports) in Latin America(all income levels) in 2005 and the Imports(as % of merchandise exports) in St. Kitts and Nevis in 2006?
Provide a succinct answer. 1.17. What is the difference between the Imports(as % of merchandise exports) of Latin America(all income levels) in 2005 and the Imports(as % of merchandise exports) of United Kingdom in 2006?
Keep it short and to the point. -0.68. What is the difference between the Imports(as % of merchandise exports) in North America in 2005 and the Imports(as % of merchandise exports) in St. Kitts and Nevis in 2006?
Make the answer very short. 0.89. What is the difference between the Imports(as % of merchandise exports) of North America in 2005 and the Imports(as % of merchandise exports) of United Kingdom in 2006?
Provide a short and direct response. -0.97. What is the difference between the Imports(as % of merchandise exports) of St. Kitts and Nevis in 2005 and the Imports(as % of merchandise exports) of United Kingdom in 2006?
Offer a very short reply. -2.43. What is the difference between the Imports(as % of merchandise exports) in Latin America(all income levels) in 2005 and the Imports(as % of merchandise exports) in North America in 2007?
Offer a very short reply. -0.33. What is the difference between the Imports(as % of merchandise exports) of Latin America(all income levels) in 2005 and the Imports(as % of merchandise exports) of St. Kitts and Nevis in 2007?
Offer a terse response. 1.55. What is the difference between the Imports(as % of merchandise exports) in Latin America(all income levels) in 2005 and the Imports(as % of merchandise exports) in United Kingdom in 2007?
Provide a succinct answer. -0.97. What is the difference between the Imports(as % of merchandise exports) in North America in 2005 and the Imports(as % of merchandise exports) in St. Kitts and Nevis in 2007?
Provide a succinct answer. 1.27. What is the difference between the Imports(as % of merchandise exports) of North America in 2005 and the Imports(as % of merchandise exports) of United Kingdom in 2007?
Your response must be concise. -1.25. What is the difference between the Imports(as % of merchandise exports) of St. Kitts and Nevis in 2005 and the Imports(as % of merchandise exports) of United Kingdom in 2007?
Offer a very short reply. -2.71. What is the difference between the Imports(as % of merchandise exports) of Latin America(all income levels) in 2005 and the Imports(as % of merchandise exports) of North America in 2008?
Provide a succinct answer. -0.13. What is the difference between the Imports(as % of merchandise exports) in Latin America(all income levels) in 2005 and the Imports(as % of merchandise exports) in St. Kitts and Nevis in 2008?
Your answer should be compact. 1.63. What is the difference between the Imports(as % of merchandise exports) in Latin America(all income levels) in 2005 and the Imports(as % of merchandise exports) in United Kingdom in 2008?
Your response must be concise. -0.98. What is the difference between the Imports(as % of merchandise exports) in North America in 2005 and the Imports(as % of merchandise exports) in St. Kitts and Nevis in 2008?
Your answer should be compact. 1.35. What is the difference between the Imports(as % of merchandise exports) of North America in 2005 and the Imports(as % of merchandise exports) of United Kingdom in 2008?
Offer a very short reply. -1.26. What is the difference between the Imports(as % of merchandise exports) of St. Kitts and Nevis in 2005 and the Imports(as % of merchandise exports) of United Kingdom in 2008?
Your answer should be compact. -2.72. What is the difference between the Imports(as % of merchandise exports) of Latin America(all income levels) in 2005 and the Imports(as % of merchandise exports) of North America in 2009?
Offer a terse response. 0.44. What is the difference between the Imports(as % of merchandise exports) of Latin America(all income levels) in 2005 and the Imports(as % of merchandise exports) of St. Kitts and Nevis in 2009?
Make the answer very short. 1.71. What is the difference between the Imports(as % of merchandise exports) in Latin America(all income levels) in 2005 and the Imports(as % of merchandise exports) in United Kingdom in 2009?
Your response must be concise. -0.49. What is the difference between the Imports(as % of merchandise exports) in North America in 2005 and the Imports(as % of merchandise exports) in St. Kitts and Nevis in 2009?
Your response must be concise. 1.43. What is the difference between the Imports(as % of merchandise exports) in North America in 2005 and the Imports(as % of merchandise exports) in United Kingdom in 2009?
Offer a terse response. -0.77. What is the difference between the Imports(as % of merchandise exports) in St. Kitts and Nevis in 2005 and the Imports(as % of merchandise exports) in United Kingdom in 2009?
Your answer should be very brief. -2.23. What is the difference between the Imports(as % of merchandise exports) of Latin America(all income levels) in 2006 and the Imports(as % of merchandise exports) of North America in 2007?
Your response must be concise. 0.16. What is the difference between the Imports(as % of merchandise exports) in Latin America(all income levels) in 2006 and the Imports(as % of merchandise exports) in St. Kitts and Nevis in 2007?
Ensure brevity in your answer.  2.04. What is the difference between the Imports(as % of merchandise exports) in Latin America(all income levels) in 2006 and the Imports(as % of merchandise exports) in United Kingdom in 2007?
Your answer should be very brief. -0.49. What is the difference between the Imports(as % of merchandise exports) of North America in 2006 and the Imports(as % of merchandise exports) of St. Kitts and Nevis in 2007?
Give a very brief answer. 1.84. What is the difference between the Imports(as % of merchandise exports) of North America in 2006 and the Imports(as % of merchandise exports) of United Kingdom in 2007?
Give a very brief answer. -0.69. What is the difference between the Imports(as % of merchandise exports) in St. Kitts and Nevis in 2006 and the Imports(as % of merchandise exports) in United Kingdom in 2007?
Offer a terse response. -2.14. What is the difference between the Imports(as % of merchandise exports) in Latin America(all income levels) in 2006 and the Imports(as % of merchandise exports) in North America in 2008?
Ensure brevity in your answer.  0.35. What is the difference between the Imports(as % of merchandise exports) of Latin America(all income levels) in 2006 and the Imports(as % of merchandise exports) of St. Kitts and Nevis in 2008?
Offer a very short reply. 2.12. What is the difference between the Imports(as % of merchandise exports) of Latin America(all income levels) in 2006 and the Imports(as % of merchandise exports) of United Kingdom in 2008?
Offer a terse response. -0.49. What is the difference between the Imports(as % of merchandise exports) of North America in 2006 and the Imports(as % of merchandise exports) of St. Kitts and Nevis in 2008?
Give a very brief answer. 1.92. What is the difference between the Imports(as % of merchandise exports) of North America in 2006 and the Imports(as % of merchandise exports) of United Kingdom in 2008?
Your answer should be very brief. -0.7. What is the difference between the Imports(as % of merchandise exports) of St. Kitts and Nevis in 2006 and the Imports(as % of merchandise exports) of United Kingdom in 2008?
Your answer should be very brief. -2.15. What is the difference between the Imports(as % of merchandise exports) of Latin America(all income levels) in 2006 and the Imports(as % of merchandise exports) of North America in 2009?
Offer a very short reply. 0.93. What is the difference between the Imports(as % of merchandise exports) of Latin America(all income levels) in 2006 and the Imports(as % of merchandise exports) of St. Kitts and Nevis in 2009?
Give a very brief answer. 2.19. What is the difference between the Imports(as % of merchandise exports) of Latin America(all income levels) in 2006 and the Imports(as % of merchandise exports) of United Kingdom in 2009?
Keep it short and to the point. -0. What is the difference between the Imports(as % of merchandise exports) of North America in 2006 and the Imports(as % of merchandise exports) of St. Kitts and Nevis in 2009?
Make the answer very short. 1.99. What is the difference between the Imports(as % of merchandise exports) of North America in 2006 and the Imports(as % of merchandise exports) of United Kingdom in 2009?
Your answer should be compact. -0.21. What is the difference between the Imports(as % of merchandise exports) of St. Kitts and Nevis in 2006 and the Imports(as % of merchandise exports) of United Kingdom in 2009?
Provide a succinct answer. -1.66. What is the difference between the Imports(as % of merchandise exports) in Latin America(all income levels) in 2007 and the Imports(as % of merchandise exports) in North America in 2008?
Ensure brevity in your answer.  0.29. What is the difference between the Imports(as % of merchandise exports) of Latin America(all income levels) in 2007 and the Imports(as % of merchandise exports) of St. Kitts and Nevis in 2008?
Keep it short and to the point. 2.06. What is the difference between the Imports(as % of merchandise exports) of Latin America(all income levels) in 2007 and the Imports(as % of merchandise exports) of United Kingdom in 2008?
Offer a very short reply. -0.55. What is the difference between the Imports(as % of merchandise exports) in North America in 2007 and the Imports(as % of merchandise exports) in St. Kitts and Nevis in 2008?
Offer a terse response. 1.96. What is the difference between the Imports(as % of merchandise exports) in North America in 2007 and the Imports(as % of merchandise exports) in United Kingdom in 2008?
Offer a terse response. -0.65. What is the difference between the Imports(as % of merchandise exports) in St. Kitts and Nevis in 2007 and the Imports(as % of merchandise exports) in United Kingdom in 2008?
Keep it short and to the point. -2.53. What is the difference between the Imports(as % of merchandise exports) of Latin America(all income levels) in 2007 and the Imports(as % of merchandise exports) of North America in 2009?
Provide a succinct answer. 0.86. What is the difference between the Imports(as % of merchandise exports) of Latin America(all income levels) in 2007 and the Imports(as % of merchandise exports) of St. Kitts and Nevis in 2009?
Provide a succinct answer. 2.13. What is the difference between the Imports(as % of merchandise exports) in Latin America(all income levels) in 2007 and the Imports(as % of merchandise exports) in United Kingdom in 2009?
Offer a very short reply. -0.07. What is the difference between the Imports(as % of merchandise exports) of North America in 2007 and the Imports(as % of merchandise exports) of St. Kitts and Nevis in 2009?
Provide a succinct answer. 2.03. What is the difference between the Imports(as % of merchandise exports) of North America in 2007 and the Imports(as % of merchandise exports) of United Kingdom in 2009?
Ensure brevity in your answer.  -0.16. What is the difference between the Imports(as % of merchandise exports) in St. Kitts and Nevis in 2007 and the Imports(as % of merchandise exports) in United Kingdom in 2009?
Your answer should be compact. -2.05. What is the difference between the Imports(as % of merchandise exports) in Latin America(all income levels) in 2008 and the Imports(as % of merchandise exports) in North America in 2009?
Your answer should be compact. 0.74. What is the difference between the Imports(as % of merchandise exports) of Latin America(all income levels) in 2008 and the Imports(as % of merchandise exports) of St. Kitts and Nevis in 2009?
Your answer should be very brief. 2.01. What is the difference between the Imports(as % of merchandise exports) of Latin America(all income levels) in 2008 and the Imports(as % of merchandise exports) of United Kingdom in 2009?
Keep it short and to the point. -0.19. What is the difference between the Imports(as % of merchandise exports) of North America in 2008 and the Imports(as % of merchandise exports) of St. Kitts and Nevis in 2009?
Provide a succinct answer. 1.84. What is the difference between the Imports(as % of merchandise exports) of North America in 2008 and the Imports(as % of merchandise exports) of United Kingdom in 2009?
Ensure brevity in your answer.  -0.36. What is the difference between the Imports(as % of merchandise exports) in St. Kitts and Nevis in 2008 and the Imports(as % of merchandise exports) in United Kingdom in 2009?
Your answer should be very brief. -2.12. What is the average Imports(as % of merchandise exports) of Latin America(all income levels) per year?
Your answer should be very brief. 2.46. What is the average Imports(as % of merchandise exports) in North America per year?
Keep it short and to the point. 2.28. What is the average Imports(as % of merchandise exports) in St. Kitts and Nevis per year?
Provide a succinct answer. 0.94. What is the average Imports(as % of merchandise exports) of United Kingdom per year?
Your response must be concise. 2.8. In the year 2002, what is the difference between the Imports(as % of merchandise exports) in Latin America(all income levels) and Imports(as % of merchandise exports) in North America?
Provide a short and direct response. 0.11. In the year 2002, what is the difference between the Imports(as % of merchandise exports) in Latin America(all income levels) and Imports(as % of merchandise exports) in St. Kitts and Nevis?
Offer a terse response. 0.57. In the year 2002, what is the difference between the Imports(as % of merchandise exports) of Latin America(all income levels) and Imports(as % of merchandise exports) of United Kingdom?
Offer a very short reply. -0.36. In the year 2002, what is the difference between the Imports(as % of merchandise exports) in North America and Imports(as % of merchandise exports) in St. Kitts and Nevis?
Your answer should be very brief. 0.46. In the year 2002, what is the difference between the Imports(as % of merchandise exports) of North America and Imports(as % of merchandise exports) of United Kingdom?
Keep it short and to the point. -0.47. In the year 2002, what is the difference between the Imports(as % of merchandise exports) in St. Kitts and Nevis and Imports(as % of merchandise exports) in United Kingdom?
Your response must be concise. -0.92. In the year 2003, what is the difference between the Imports(as % of merchandise exports) of Latin America(all income levels) and Imports(as % of merchandise exports) of North America?
Give a very brief answer. 0.3. In the year 2003, what is the difference between the Imports(as % of merchandise exports) in Latin America(all income levels) and Imports(as % of merchandise exports) in St. Kitts and Nevis?
Your answer should be compact. 1.35. In the year 2003, what is the difference between the Imports(as % of merchandise exports) in Latin America(all income levels) and Imports(as % of merchandise exports) in United Kingdom?
Give a very brief answer. -0.17. In the year 2003, what is the difference between the Imports(as % of merchandise exports) in North America and Imports(as % of merchandise exports) in St. Kitts and Nevis?
Your response must be concise. 1.05. In the year 2003, what is the difference between the Imports(as % of merchandise exports) in North America and Imports(as % of merchandise exports) in United Kingdom?
Keep it short and to the point. -0.48. In the year 2003, what is the difference between the Imports(as % of merchandise exports) of St. Kitts and Nevis and Imports(as % of merchandise exports) of United Kingdom?
Your answer should be very brief. -1.52. In the year 2004, what is the difference between the Imports(as % of merchandise exports) of Latin America(all income levels) and Imports(as % of merchandise exports) of North America?
Provide a succinct answer. 0.34. In the year 2004, what is the difference between the Imports(as % of merchandise exports) of Latin America(all income levels) and Imports(as % of merchandise exports) of St. Kitts and Nevis?
Make the answer very short. 1.73. In the year 2004, what is the difference between the Imports(as % of merchandise exports) of Latin America(all income levels) and Imports(as % of merchandise exports) of United Kingdom?
Provide a succinct answer. 0.11. In the year 2004, what is the difference between the Imports(as % of merchandise exports) of North America and Imports(as % of merchandise exports) of St. Kitts and Nevis?
Make the answer very short. 1.39. In the year 2004, what is the difference between the Imports(as % of merchandise exports) of North America and Imports(as % of merchandise exports) of United Kingdom?
Give a very brief answer. -0.24. In the year 2004, what is the difference between the Imports(as % of merchandise exports) of St. Kitts and Nevis and Imports(as % of merchandise exports) of United Kingdom?
Your answer should be very brief. -1.62. In the year 2005, what is the difference between the Imports(as % of merchandise exports) in Latin America(all income levels) and Imports(as % of merchandise exports) in North America?
Your answer should be very brief. 0.28. In the year 2005, what is the difference between the Imports(as % of merchandise exports) of Latin America(all income levels) and Imports(as % of merchandise exports) of St. Kitts and Nevis?
Keep it short and to the point. 1.74. In the year 2005, what is the difference between the Imports(as % of merchandise exports) in Latin America(all income levels) and Imports(as % of merchandise exports) in United Kingdom?
Keep it short and to the point. 0.08. In the year 2005, what is the difference between the Imports(as % of merchandise exports) in North America and Imports(as % of merchandise exports) in St. Kitts and Nevis?
Keep it short and to the point. 1.46. In the year 2005, what is the difference between the Imports(as % of merchandise exports) of North America and Imports(as % of merchandise exports) of United Kingdom?
Your answer should be compact. -0.2. In the year 2005, what is the difference between the Imports(as % of merchandise exports) of St. Kitts and Nevis and Imports(as % of merchandise exports) of United Kingdom?
Keep it short and to the point. -1.66. In the year 2006, what is the difference between the Imports(as % of merchandise exports) of Latin America(all income levels) and Imports(as % of merchandise exports) of North America?
Offer a very short reply. 0.21. In the year 2006, what is the difference between the Imports(as % of merchandise exports) of Latin America(all income levels) and Imports(as % of merchandise exports) of St. Kitts and Nevis?
Make the answer very short. 1.66. In the year 2006, what is the difference between the Imports(as % of merchandise exports) in Latin America(all income levels) and Imports(as % of merchandise exports) in United Kingdom?
Your answer should be compact. -0.2. In the year 2006, what is the difference between the Imports(as % of merchandise exports) in North America and Imports(as % of merchandise exports) in St. Kitts and Nevis?
Give a very brief answer. 1.45. In the year 2006, what is the difference between the Imports(as % of merchandise exports) of North America and Imports(as % of merchandise exports) of United Kingdom?
Offer a very short reply. -0.4. In the year 2006, what is the difference between the Imports(as % of merchandise exports) in St. Kitts and Nevis and Imports(as % of merchandise exports) in United Kingdom?
Make the answer very short. -1.85. In the year 2007, what is the difference between the Imports(as % of merchandise exports) in Latin America(all income levels) and Imports(as % of merchandise exports) in North America?
Provide a succinct answer. 0.1. In the year 2007, what is the difference between the Imports(as % of merchandise exports) in Latin America(all income levels) and Imports(as % of merchandise exports) in St. Kitts and Nevis?
Offer a very short reply. 1.98. In the year 2007, what is the difference between the Imports(as % of merchandise exports) in Latin America(all income levels) and Imports(as % of merchandise exports) in United Kingdom?
Keep it short and to the point. -0.55. In the year 2007, what is the difference between the Imports(as % of merchandise exports) of North America and Imports(as % of merchandise exports) of St. Kitts and Nevis?
Offer a very short reply. 1.88. In the year 2007, what is the difference between the Imports(as % of merchandise exports) of North America and Imports(as % of merchandise exports) of United Kingdom?
Your answer should be very brief. -0.65. In the year 2007, what is the difference between the Imports(as % of merchandise exports) in St. Kitts and Nevis and Imports(as % of merchandise exports) in United Kingdom?
Your answer should be very brief. -2.53. In the year 2008, what is the difference between the Imports(as % of merchandise exports) in Latin America(all income levels) and Imports(as % of merchandise exports) in North America?
Your response must be concise. 0.17. In the year 2008, what is the difference between the Imports(as % of merchandise exports) of Latin America(all income levels) and Imports(as % of merchandise exports) of St. Kitts and Nevis?
Your answer should be very brief. 1.94. In the year 2008, what is the difference between the Imports(as % of merchandise exports) of Latin America(all income levels) and Imports(as % of merchandise exports) of United Kingdom?
Make the answer very short. -0.67. In the year 2008, what is the difference between the Imports(as % of merchandise exports) of North America and Imports(as % of merchandise exports) of St. Kitts and Nevis?
Offer a very short reply. 1.77. In the year 2008, what is the difference between the Imports(as % of merchandise exports) of North America and Imports(as % of merchandise exports) of United Kingdom?
Provide a short and direct response. -0.84. In the year 2008, what is the difference between the Imports(as % of merchandise exports) of St. Kitts and Nevis and Imports(as % of merchandise exports) of United Kingdom?
Provide a succinct answer. -2.61. In the year 2009, what is the difference between the Imports(as % of merchandise exports) of Latin America(all income levels) and Imports(as % of merchandise exports) of North America?
Provide a short and direct response. -0.05. In the year 2009, what is the difference between the Imports(as % of merchandise exports) of Latin America(all income levels) and Imports(as % of merchandise exports) of St. Kitts and Nevis?
Ensure brevity in your answer.  1.22. In the year 2009, what is the difference between the Imports(as % of merchandise exports) in Latin America(all income levels) and Imports(as % of merchandise exports) in United Kingdom?
Keep it short and to the point. -0.98. In the year 2009, what is the difference between the Imports(as % of merchandise exports) of North America and Imports(as % of merchandise exports) of St. Kitts and Nevis?
Keep it short and to the point. 1.27. In the year 2009, what is the difference between the Imports(as % of merchandise exports) in North America and Imports(as % of merchandise exports) in United Kingdom?
Provide a succinct answer. -0.93. In the year 2009, what is the difference between the Imports(as % of merchandise exports) of St. Kitts and Nevis and Imports(as % of merchandise exports) of United Kingdom?
Provide a short and direct response. -2.2. What is the ratio of the Imports(as % of merchandise exports) in Latin America(all income levels) in 2002 to that in 2003?
Provide a short and direct response. 0.95. What is the ratio of the Imports(as % of merchandise exports) of North America in 2002 to that in 2003?
Keep it short and to the point. 1.05. What is the ratio of the Imports(as % of merchandise exports) in St. Kitts and Nevis in 2002 to that in 2003?
Provide a succinct answer. 1.97. What is the ratio of the Imports(as % of merchandise exports) in United Kingdom in 2002 to that in 2003?
Make the answer very short. 1.04. What is the ratio of the Imports(as % of merchandise exports) of Latin America(all income levels) in 2002 to that in 2004?
Make the answer very short. 0.81. What is the ratio of the Imports(as % of merchandise exports) of North America in 2002 to that in 2004?
Ensure brevity in your answer.  0.89. What is the ratio of the Imports(as % of merchandise exports) in St. Kitts and Nevis in 2002 to that in 2004?
Your answer should be very brief. 1.98. What is the ratio of the Imports(as % of merchandise exports) of United Kingdom in 2002 to that in 2004?
Give a very brief answer. 1. What is the ratio of the Imports(as % of merchandise exports) in Latin America(all income levels) in 2002 to that in 2005?
Give a very brief answer. 0.78. What is the ratio of the Imports(as % of merchandise exports) of North America in 2002 to that in 2005?
Make the answer very short. 0.83. What is the ratio of the Imports(as % of merchandise exports) in St. Kitts and Nevis in 2002 to that in 2005?
Your answer should be very brief. 1.83. What is the ratio of the Imports(as % of merchandise exports) in United Kingdom in 2002 to that in 2005?
Offer a terse response. 0.96. What is the ratio of the Imports(as % of merchandise exports) in Latin America(all income levels) in 2002 to that in 2006?
Make the answer very short. 0.66. What is the ratio of the Imports(as % of merchandise exports) of North America in 2002 to that in 2006?
Provide a short and direct response. 0.67. What is the ratio of the Imports(as % of merchandise exports) of St. Kitts and Nevis in 2002 to that in 2006?
Keep it short and to the point. 1.04. What is the ratio of the Imports(as % of merchandise exports) of United Kingdom in 2002 to that in 2006?
Offer a very short reply. 0.73. What is the ratio of the Imports(as % of merchandise exports) in Latin America(all income levels) in 2002 to that in 2007?
Offer a terse response. 0.67. What is the ratio of the Imports(as % of merchandise exports) of North America in 2002 to that in 2007?
Offer a very short reply. 0.65. What is the ratio of the Imports(as % of merchandise exports) of St. Kitts and Nevis in 2002 to that in 2007?
Your response must be concise. 1.47. What is the ratio of the Imports(as % of merchandise exports) of United Kingdom in 2002 to that in 2007?
Offer a very short reply. 0.67. What is the ratio of the Imports(as % of merchandise exports) in Latin America(all income levels) in 2002 to that in 2008?
Your answer should be compact. 0.7. What is the ratio of the Imports(as % of merchandise exports) in North America in 2002 to that in 2008?
Ensure brevity in your answer.  0.7. What is the ratio of the Imports(as % of merchandise exports) of St. Kitts and Nevis in 2002 to that in 2008?
Your response must be concise. 1.61. What is the ratio of the Imports(as % of merchandise exports) of United Kingdom in 2002 to that in 2008?
Ensure brevity in your answer.  0.67. What is the ratio of the Imports(as % of merchandise exports) of Latin America(all income levels) in 2002 to that in 2009?
Keep it short and to the point. 0.97. What is the ratio of the Imports(as % of merchandise exports) of North America in 2002 to that in 2009?
Keep it short and to the point. 0.9. What is the ratio of the Imports(as % of merchandise exports) of St. Kitts and Nevis in 2002 to that in 2009?
Offer a terse response. 1.75. What is the ratio of the Imports(as % of merchandise exports) of United Kingdom in 2002 to that in 2009?
Make the answer very short. 0.77. What is the ratio of the Imports(as % of merchandise exports) of Latin America(all income levels) in 2003 to that in 2004?
Ensure brevity in your answer.  0.85. What is the ratio of the Imports(as % of merchandise exports) in North America in 2003 to that in 2004?
Your answer should be very brief. 0.84. What is the ratio of the Imports(as % of merchandise exports) in Latin America(all income levels) in 2003 to that in 2005?
Offer a very short reply. 0.82. What is the ratio of the Imports(as % of merchandise exports) in North America in 2003 to that in 2005?
Your answer should be compact. 0.79. What is the ratio of the Imports(as % of merchandise exports) in St. Kitts and Nevis in 2003 to that in 2005?
Provide a short and direct response. 0.93. What is the ratio of the Imports(as % of merchandise exports) of United Kingdom in 2003 to that in 2005?
Provide a succinct answer. 0.92. What is the ratio of the Imports(as % of merchandise exports) in Latin America(all income levels) in 2003 to that in 2006?
Provide a short and direct response. 0.69. What is the ratio of the Imports(as % of merchandise exports) in North America in 2003 to that in 2006?
Your answer should be compact. 0.63. What is the ratio of the Imports(as % of merchandise exports) of St. Kitts and Nevis in 2003 to that in 2006?
Your answer should be very brief. 0.53. What is the ratio of the Imports(as % of merchandise exports) of United Kingdom in 2003 to that in 2006?
Ensure brevity in your answer.  0.7. What is the ratio of the Imports(as % of merchandise exports) in Latin America(all income levels) in 2003 to that in 2007?
Make the answer very short. 0.7. What is the ratio of the Imports(as % of merchandise exports) of North America in 2003 to that in 2007?
Offer a terse response. 0.62. What is the ratio of the Imports(as % of merchandise exports) of St. Kitts and Nevis in 2003 to that in 2007?
Give a very brief answer. 0.75. What is the ratio of the Imports(as % of merchandise exports) in United Kingdom in 2003 to that in 2007?
Offer a very short reply. 0.64. What is the ratio of the Imports(as % of merchandise exports) in Latin America(all income levels) in 2003 to that in 2008?
Make the answer very short. 0.73. What is the ratio of the Imports(as % of merchandise exports) of North America in 2003 to that in 2008?
Your response must be concise. 0.67. What is the ratio of the Imports(as % of merchandise exports) of St. Kitts and Nevis in 2003 to that in 2008?
Your answer should be compact. 0.81. What is the ratio of the Imports(as % of merchandise exports) in United Kingdom in 2003 to that in 2008?
Keep it short and to the point. 0.64. What is the ratio of the Imports(as % of merchandise exports) in Latin America(all income levels) in 2003 to that in 2009?
Offer a terse response. 1.02. What is the ratio of the Imports(as % of merchandise exports) in North America in 2003 to that in 2009?
Keep it short and to the point. 0.85. What is the ratio of the Imports(as % of merchandise exports) of St. Kitts and Nevis in 2003 to that in 2009?
Offer a very short reply. 0.89. What is the ratio of the Imports(as % of merchandise exports) in United Kingdom in 2003 to that in 2009?
Offer a terse response. 0.75. What is the ratio of the Imports(as % of merchandise exports) in Latin America(all income levels) in 2004 to that in 2005?
Offer a very short reply. 0.97. What is the ratio of the Imports(as % of merchandise exports) in St. Kitts and Nevis in 2004 to that in 2005?
Provide a short and direct response. 0.92. What is the ratio of the Imports(as % of merchandise exports) in United Kingdom in 2004 to that in 2005?
Your answer should be compact. 0.96. What is the ratio of the Imports(as % of merchandise exports) of Latin America(all income levels) in 2004 to that in 2006?
Give a very brief answer. 0.81. What is the ratio of the Imports(as % of merchandise exports) in North America in 2004 to that in 2006?
Your answer should be very brief. 0.75. What is the ratio of the Imports(as % of merchandise exports) of St. Kitts and Nevis in 2004 to that in 2006?
Provide a short and direct response. 0.53. What is the ratio of the Imports(as % of merchandise exports) in United Kingdom in 2004 to that in 2006?
Provide a succinct answer. 0.73. What is the ratio of the Imports(as % of merchandise exports) in Latin America(all income levels) in 2004 to that in 2007?
Make the answer very short. 0.83. What is the ratio of the Imports(as % of merchandise exports) in North America in 2004 to that in 2007?
Your answer should be compact. 0.74. What is the ratio of the Imports(as % of merchandise exports) in St. Kitts and Nevis in 2004 to that in 2007?
Your response must be concise. 0.74. What is the ratio of the Imports(as % of merchandise exports) of United Kingdom in 2004 to that in 2007?
Offer a terse response. 0.67. What is the ratio of the Imports(as % of merchandise exports) in Latin America(all income levels) in 2004 to that in 2008?
Your answer should be very brief. 0.87. What is the ratio of the Imports(as % of merchandise exports) of North America in 2004 to that in 2008?
Ensure brevity in your answer.  0.79. What is the ratio of the Imports(as % of merchandise exports) of St. Kitts and Nevis in 2004 to that in 2008?
Provide a succinct answer. 0.81. What is the ratio of the Imports(as % of merchandise exports) of United Kingdom in 2004 to that in 2008?
Offer a very short reply. 0.67. What is the ratio of the Imports(as % of merchandise exports) of Latin America(all income levels) in 2004 to that in 2009?
Make the answer very short. 1.21. What is the ratio of the Imports(as % of merchandise exports) of North America in 2004 to that in 2009?
Your response must be concise. 1.01. What is the ratio of the Imports(as % of merchandise exports) of St. Kitts and Nevis in 2004 to that in 2009?
Keep it short and to the point. 0.88. What is the ratio of the Imports(as % of merchandise exports) of United Kingdom in 2004 to that in 2009?
Provide a short and direct response. 0.78. What is the ratio of the Imports(as % of merchandise exports) of Latin America(all income levels) in 2005 to that in 2006?
Make the answer very short. 0.84. What is the ratio of the Imports(as % of merchandise exports) in North America in 2005 to that in 2006?
Your answer should be compact. 0.8. What is the ratio of the Imports(as % of merchandise exports) of St. Kitts and Nevis in 2005 to that in 2006?
Give a very brief answer. 0.57. What is the ratio of the Imports(as % of merchandise exports) in United Kingdom in 2005 to that in 2006?
Make the answer very short. 0.76. What is the ratio of the Imports(as % of merchandise exports) of Latin America(all income levels) in 2005 to that in 2007?
Offer a very short reply. 0.86. What is the ratio of the Imports(as % of merchandise exports) in North America in 2005 to that in 2007?
Provide a succinct answer. 0.78. What is the ratio of the Imports(as % of merchandise exports) in St. Kitts and Nevis in 2005 to that in 2007?
Give a very brief answer. 0.8. What is the ratio of the Imports(as % of merchandise exports) in United Kingdom in 2005 to that in 2007?
Keep it short and to the point. 0.7. What is the ratio of the Imports(as % of merchandise exports) of Latin America(all income levels) in 2005 to that in 2008?
Offer a terse response. 0.89. What is the ratio of the Imports(as % of merchandise exports) of North America in 2005 to that in 2008?
Make the answer very short. 0.84. What is the ratio of the Imports(as % of merchandise exports) of St. Kitts and Nevis in 2005 to that in 2008?
Provide a short and direct response. 0.88. What is the ratio of the Imports(as % of merchandise exports) of United Kingdom in 2005 to that in 2008?
Your response must be concise. 0.7. What is the ratio of the Imports(as % of merchandise exports) in Latin America(all income levels) in 2005 to that in 2009?
Give a very brief answer. 1.24. What is the ratio of the Imports(as % of merchandise exports) of North America in 2005 to that in 2009?
Give a very brief answer. 1.08. What is the ratio of the Imports(as % of merchandise exports) of St. Kitts and Nevis in 2005 to that in 2009?
Your answer should be very brief. 0.96. What is the ratio of the Imports(as % of merchandise exports) in United Kingdom in 2005 to that in 2009?
Keep it short and to the point. 0.81. What is the ratio of the Imports(as % of merchandise exports) in Latin America(all income levels) in 2006 to that in 2007?
Ensure brevity in your answer.  1.02. What is the ratio of the Imports(as % of merchandise exports) in North America in 2006 to that in 2007?
Offer a terse response. 0.98. What is the ratio of the Imports(as % of merchandise exports) in St. Kitts and Nevis in 2006 to that in 2007?
Your answer should be compact. 1.41. What is the ratio of the Imports(as % of merchandise exports) of United Kingdom in 2006 to that in 2007?
Your answer should be very brief. 0.92. What is the ratio of the Imports(as % of merchandise exports) of Latin America(all income levels) in 2006 to that in 2008?
Your response must be concise. 1.07. What is the ratio of the Imports(as % of merchandise exports) of North America in 2006 to that in 2008?
Your answer should be compact. 1.06. What is the ratio of the Imports(as % of merchandise exports) in St. Kitts and Nevis in 2006 to that in 2008?
Provide a succinct answer. 1.54. What is the ratio of the Imports(as % of merchandise exports) of United Kingdom in 2006 to that in 2008?
Offer a terse response. 0.92. What is the ratio of the Imports(as % of merchandise exports) of Latin America(all income levels) in 2006 to that in 2009?
Your answer should be very brief. 1.49. What is the ratio of the Imports(as % of merchandise exports) in North America in 2006 to that in 2009?
Keep it short and to the point. 1.35. What is the ratio of the Imports(as % of merchandise exports) in St. Kitts and Nevis in 2006 to that in 2009?
Your response must be concise. 1.68. What is the ratio of the Imports(as % of merchandise exports) in United Kingdom in 2006 to that in 2009?
Offer a terse response. 1.06. What is the ratio of the Imports(as % of merchandise exports) of Latin America(all income levels) in 2007 to that in 2008?
Your response must be concise. 1.04. What is the ratio of the Imports(as % of merchandise exports) of North America in 2007 to that in 2008?
Your answer should be very brief. 1.07. What is the ratio of the Imports(as % of merchandise exports) of St. Kitts and Nevis in 2007 to that in 2008?
Offer a terse response. 1.09. What is the ratio of the Imports(as % of merchandise exports) of Latin America(all income levels) in 2007 to that in 2009?
Offer a terse response. 1.45. What is the ratio of the Imports(as % of merchandise exports) of North America in 2007 to that in 2009?
Ensure brevity in your answer.  1.37. What is the ratio of the Imports(as % of merchandise exports) of St. Kitts and Nevis in 2007 to that in 2009?
Your response must be concise. 1.19. What is the ratio of the Imports(as % of merchandise exports) in United Kingdom in 2007 to that in 2009?
Ensure brevity in your answer.  1.16. What is the ratio of the Imports(as % of merchandise exports) in Latin America(all income levels) in 2008 to that in 2009?
Your response must be concise. 1.39. What is the ratio of the Imports(as % of merchandise exports) in North America in 2008 to that in 2009?
Give a very brief answer. 1.28. What is the ratio of the Imports(as % of merchandise exports) of St. Kitts and Nevis in 2008 to that in 2009?
Offer a very short reply. 1.09. What is the ratio of the Imports(as % of merchandise exports) of United Kingdom in 2008 to that in 2009?
Give a very brief answer. 1.16. What is the difference between the highest and the second highest Imports(as % of merchandise exports) in Latin America(all income levels)?
Offer a terse response. 0.07. What is the difference between the highest and the second highest Imports(as % of merchandise exports) of North America?
Keep it short and to the point. 0.05. What is the difference between the highest and the second highest Imports(as % of merchandise exports) in United Kingdom?
Your answer should be compact. 0. What is the difference between the highest and the lowest Imports(as % of merchandise exports) in Latin America(all income levels)?
Your answer should be compact. 1.03. What is the difference between the highest and the lowest Imports(as % of merchandise exports) in North America?
Provide a short and direct response. 1.07. What is the difference between the highest and the lowest Imports(as % of merchandise exports) in St. Kitts and Nevis?
Ensure brevity in your answer.  0.69. What is the difference between the highest and the lowest Imports(as % of merchandise exports) in United Kingdom?
Your response must be concise. 1.25. 